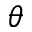<formula> <loc_0><loc_0><loc_500><loc_500>\theta</formula> 